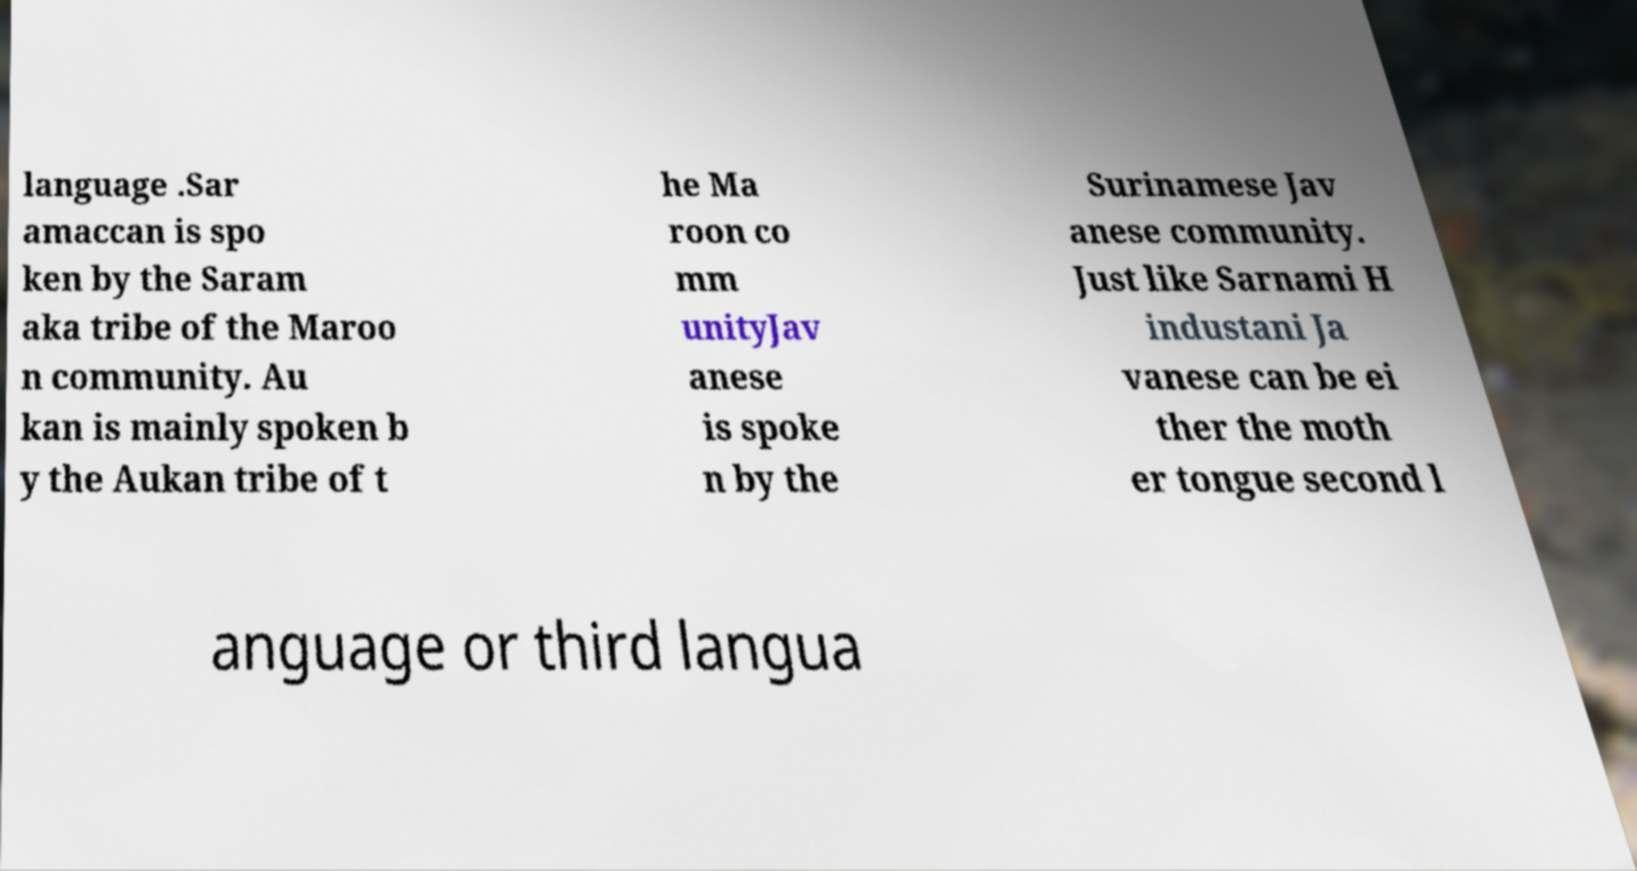Could you assist in decoding the text presented in this image and type it out clearly? language .Sar amaccan is spo ken by the Saram aka tribe of the Maroo n community. Au kan is mainly spoken b y the Aukan tribe of t he Ma roon co mm unityJav anese is spoke n by the Surinamese Jav anese community. Just like Sarnami H industani Ja vanese can be ei ther the moth er tongue second l anguage or third langua 